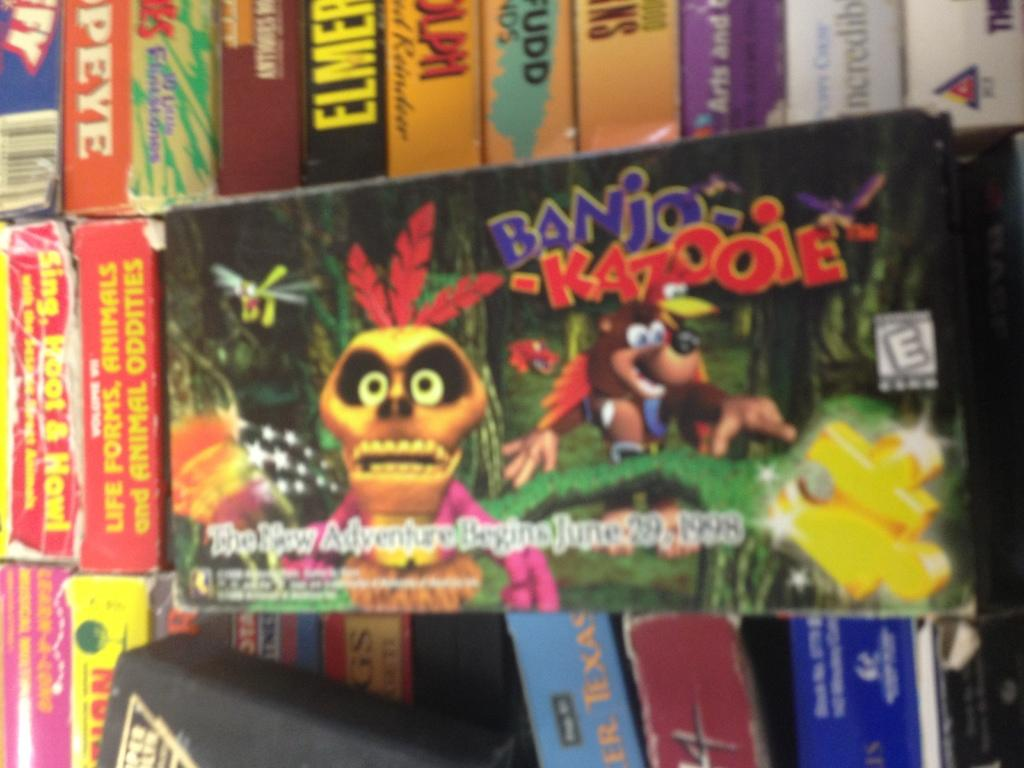Provide a one-sentence caption for the provided image. Next to tattered and torn items an Old Banjo and Kazooie game is placed front and center. 